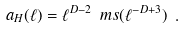<formula> <loc_0><loc_0><loc_500><loc_500>a _ { H } ( \ell ) = \ell ^ { D - 2 } \ m s ( \ell ^ { - D + 3 } ) \ .</formula> 